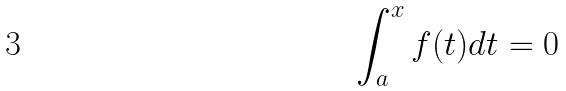<formula> <loc_0><loc_0><loc_500><loc_500>\int _ { a } ^ { x } f ( t ) d t = 0</formula> 